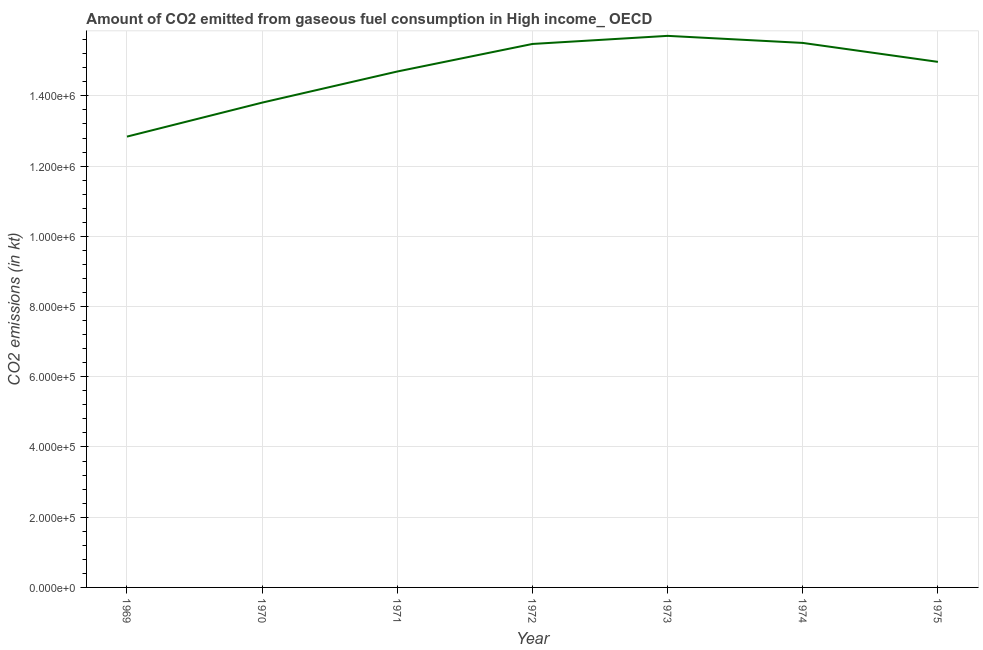What is the co2 emissions from gaseous fuel consumption in 1971?
Your answer should be very brief. 1.47e+06. Across all years, what is the maximum co2 emissions from gaseous fuel consumption?
Offer a very short reply. 1.57e+06. Across all years, what is the minimum co2 emissions from gaseous fuel consumption?
Ensure brevity in your answer.  1.28e+06. In which year was the co2 emissions from gaseous fuel consumption minimum?
Offer a terse response. 1969. What is the sum of the co2 emissions from gaseous fuel consumption?
Offer a very short reply. 1.03e+07. What is the difference between the co2 emissions from gaseous fuel consumption in 1971 and 1973?
Offer a very short reply. -1.01e+05. What is the average co2 emissions from gaseous fuel consumption per year?
Your response must be concise. 1.47e+06. What is the median co2 emissions from gaseous fuel consumption?
Your answer should be compact. 1.50e+06. What is the ratio of the co2 emissions from gaseous fuel consumption in 1970 to that in 1973?
Provide a succinct answer. 0.88. Is the co2 emissions from gaseous fuel consumption in 1970 less than that in 1973?
Offer a terse response. Yes. What is the difference between the highest and the second highest co2 emissions from gaseous fuel consumption?
Ensure brevity in your answer.  2.01e+04. What is the difference between the highest and the lowest co2 emissions from gaseous fuel consumption?
Keep it short and to the point. 2.87e+05. How many years are there in the graph?
Offer a very short reply. 7. What is the title of the graph?
Your response must be concise. Amount of CO2 emitted from gaseous fuel consumption in High income_ OECD. What is the label or title of the Y-axis?
Your answer should be compact. CO2 emissions (in kt). What is the CO2 emissions (in kt) of 1969?
Your answer should be very brief. 1.28e+06. What is the CO2 emissions (in kt) in 1970?
Give a very brief answer. 1.38e+06. What is the CO2 emissions (in kt) in 1971?
Provide a short and direct response. 1.47e+06. What is the CO2 emissions (in kt) in 1972?
Make the answer very short. 1.55e+06. What is the CO2 emissions (in kt) in 1973?
Keep it short and to the point. 1.57e+06. What is the CO2 emissions (in kt) in 1974?
Offer a very short reply. 1.55e+06. What is the CO2 emissions (in kt) in 1975?
Keep it short and to the point. 1.50e+06. What is the difference between the CO2 emissions (in kt) in 1969 and 1970?
Your answer should be very brief. -9.68e+04. What is the difference between the CO2 emissions (in kt) in 1969 and 1971?
Your answer should be very brief. -1.85e+05. What is the difference between the CO2 emissions (in kt) in 1969 and 1972?
Offer a very short reply. -2.64e+05. What is the difference between the CO2 emissions (in kt) in 1969 and 1973?
Provide a short and direct response. -2.87e+05. What is the difference between the CO2 emissions (in kt) in 1969 and 1974?
Offer a terse response. -2.67e+05. What is the difference between the CO2 emissions (in kt) in 1969 and 1975?
Your response must be concise. -2.13e+05. What is the difference between the CO2 emissions (in kt) in 1970 and 1971?
Your answer should be compact. -8.86e+04. What is the difference between the CO2 emissions (in kt) in 1970 and 1972?
Your answer should be very brief. -1.67e+05. What is the difference between the CO2 emissions (in kt) in 1970 and 1973?
Keep it short and to the point. -1.90e+05. What is the difference between the CO2 emissions (in kt) in 1970 and 1974?
Your response must be concise. -1.70e+05. What is the difference between the CO2 emissions (in kt) in 1970 and 1975?
Your response must be concise. -1.16e+05. What is the difference between the CO2 emissions (in kt) in 1971 and 1972?
Keep it short and to the point. -7.85e+04. What is the difference between the CO2 emissions (in kt) in 1971 and 1973?
Give a very brief answer. -1.01e+05. What is the difference between the CO2 emissions (in kt) in 1971 and 1974?
Provide a short and direct response. -8.14e+04. What is the difference between the CO2 emissions (in kt) in 1971 and 1975?
Give a very brief answer. -2.74e+04. What is the difference between the CO2 emissions (in kt) in 1972 and 1973?
Give a very brief answer. -2.30e+04. What is the difference between the CO2 emissions (in kt) in 1972 and 1974?
Your answer should be compact. -2914.47. What is the difference between the CO2 emissions (in kt) in 1972 and 1975?
Give a very brief answer. 5.10e+04. What is the difference between the CO2 emissions (in kt) in 1973 and 1974?
Give a very brief answer. 2.01e+04. What is the difference between the CO2 emissions (in kt) in 1973 and 1975?
Ensure brevity in your answer.  7.41e+04. What is the difference between the CO2 emissions (in kt) in 1974 and 1975?
Your answer should be very brief. 5.39e+04. What is the ratio of the CO2 emissions (in kt) in 1969 to that in 1971?
Make the answer very short. 0.87. What is the ratio of the CO2 emissions (in kt) in 1969 to that in 1972?
Provide a succinct answer. 0.83. What is the ratio of the CO2 emissions (in kt) in 1969 to that in 1973?
Ensure brevity in your answer.  0.82. What is the ratio of the CO2 emissions (in kt) in 1969 to that in 1974?
Your answer should be compact. 0.83. What is the ratio of the CO2 emissions (in kt) in 1969 to that in 1975?
Provide a succinct answer. 0.86. What is the ratio of the CO2 emissions (in kt) in 1970 to that in 1972?
Your response must be concise. 0.89. What is the ratio of the CO2 emissions (in kt) in 1970 to that in 1973?
Make the answer very short. 0.88. What is the ratio of the CO2 emissions (in kt) in 1970 to that in 1974?
Provide a short and direct response. 0.89. What is the ratio of the CO2 emissions (in kt) in 1970 to that in 1975?
Your answer should be compact. 0.92. What is the ratio of the CO2 emissions (in kt) in 1971 to that in 1972?
Ensure brevity in your answer.  0.95. What is the ratio of the CO2 emissions (in kt) in 1971 to that in 1973?
Keep it short and to the point. 0.94. What is the ratio of the CO2 emissions (in kt) in 1971 to that in 1974?
Offer a very short reply. 0.95. What is the ratio of the CO2 emissions (in kt) in 1972 to that in 1973?
Give a very brief answer. 0.98. What is the ratio of the CO2 emissions (in kt) in 1972 to that in 1974?
Your answer should be compact. 1. What is the ratio of the CO2 emissions (in kt) in 1972 to that in 1975?
Provide a short and direct response. 1.03. What is the ratio of the CO2 emissions (in kt) in 1973 to that in 1975?
Your answer should be very brief. 1.05. What is the ratio of the CO2 emissions (in kt) in 1974 to that in 1975?
Ensure brevity in your answer.  1.04. 